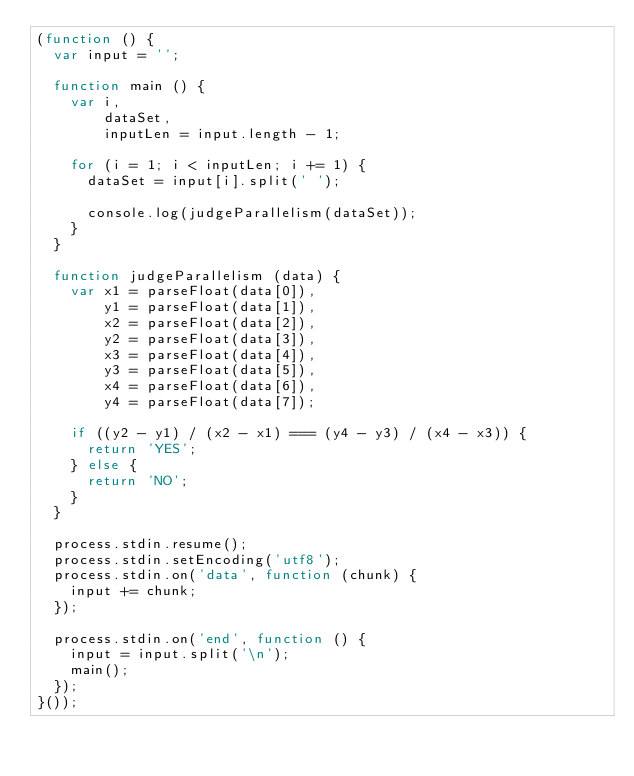Convert code to text. <code><loc_0><loc_0><loc_500><loc_500><_JavaScript_>(function () {
  var input = '';

  function main () {
    var i, 
        dataSet,
        inputLen = input.length - 1;

    for (i = 1; i < inputLen; i += 1) {
      dataSet = input[i].split(' ');

      console.log(judgeParallelism(dataSet));
    }
  }

  function judgeParallelism (data) {
    var x1 = parseFloat(data[0]),
        y1 = parseFloat(data[1]),
        x2 = parseFloat(data[2]),
        y2 = parseFloat(data[3]),
        x3 = parseFloat(data[4]),
        y3 = parseFloat(data[5]),
        x4 = parseFloat(data[6]),
        y4 = parseFloat(data[7]);

    if ((y2 - y1) / (x2 - x1) === (y4 - y3) / (x4 - x3)) {
      return 'YES';
    } else {
      return 'NO';
    }
  }

  process.stdin.resume();
  process.stdin.setEncoding('utf8');
  process.stdin.on('data', function (chunk) {
    input += chunk;
  });

  process.stdin.on('end', function () {
    input = input.split('\n');
    main();
  });
}());</code> 